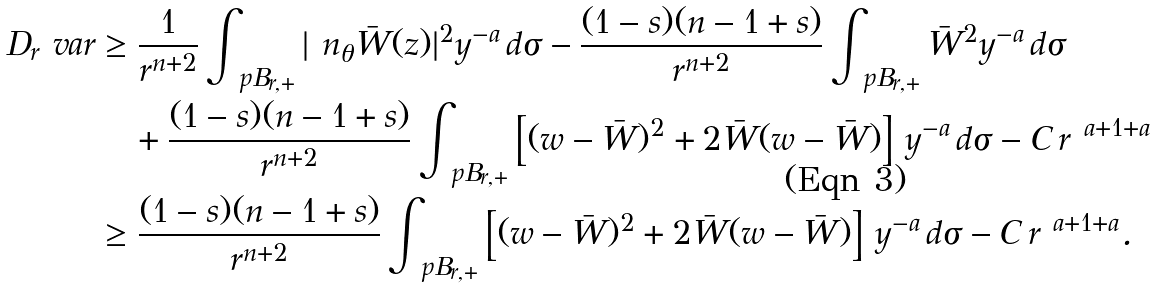<formula> <loc_0><loc_0><loc_500><loc_500>D _ { r } \ v a r & \geq \frac { 1 } { r ^ { n + 2 } } \int _ { \ p B _ { r , + } } | \ n _ { \theta } \bar { W } ( z ) | ^ { 2 } y ^ { - a } \, d \sigma - \frac { ( 1 - s ) ( n - 1 + s ) } { r ^ { n + 2 } } \int _ { \ p B _ { r , + } } \bar { W } ^ { 2 } y ^ { - a } \, d \sigma \\ & \quad + \frac { ( 1 - s ) ( n - 1 + s ) } { r ^ { n + 2 } } \int _ { \ p B _ { r , + } } \left [ ( w - \bar { W } ) ^ { 2 } + 2 \bar { W } ( w - \bar { W } ) \right ] \, y ^ { - a } \, d \sigma - C \, r ^ { \ a + 1 + a } \\ & \geq \frac { ( 1 - s ) ( n - 1 + s ) } { r ^ { n + 2 } } \int _ { \ p B _ { r , + } } \left [ ( w - \bar { W } ) ^ { 2 } + 2 \bar { W } ( w - \bar { W } ) \right ] \, y ^ { - a } \, d \sigma - C \, r ^ { \ a + 1 + a } .</formula> 